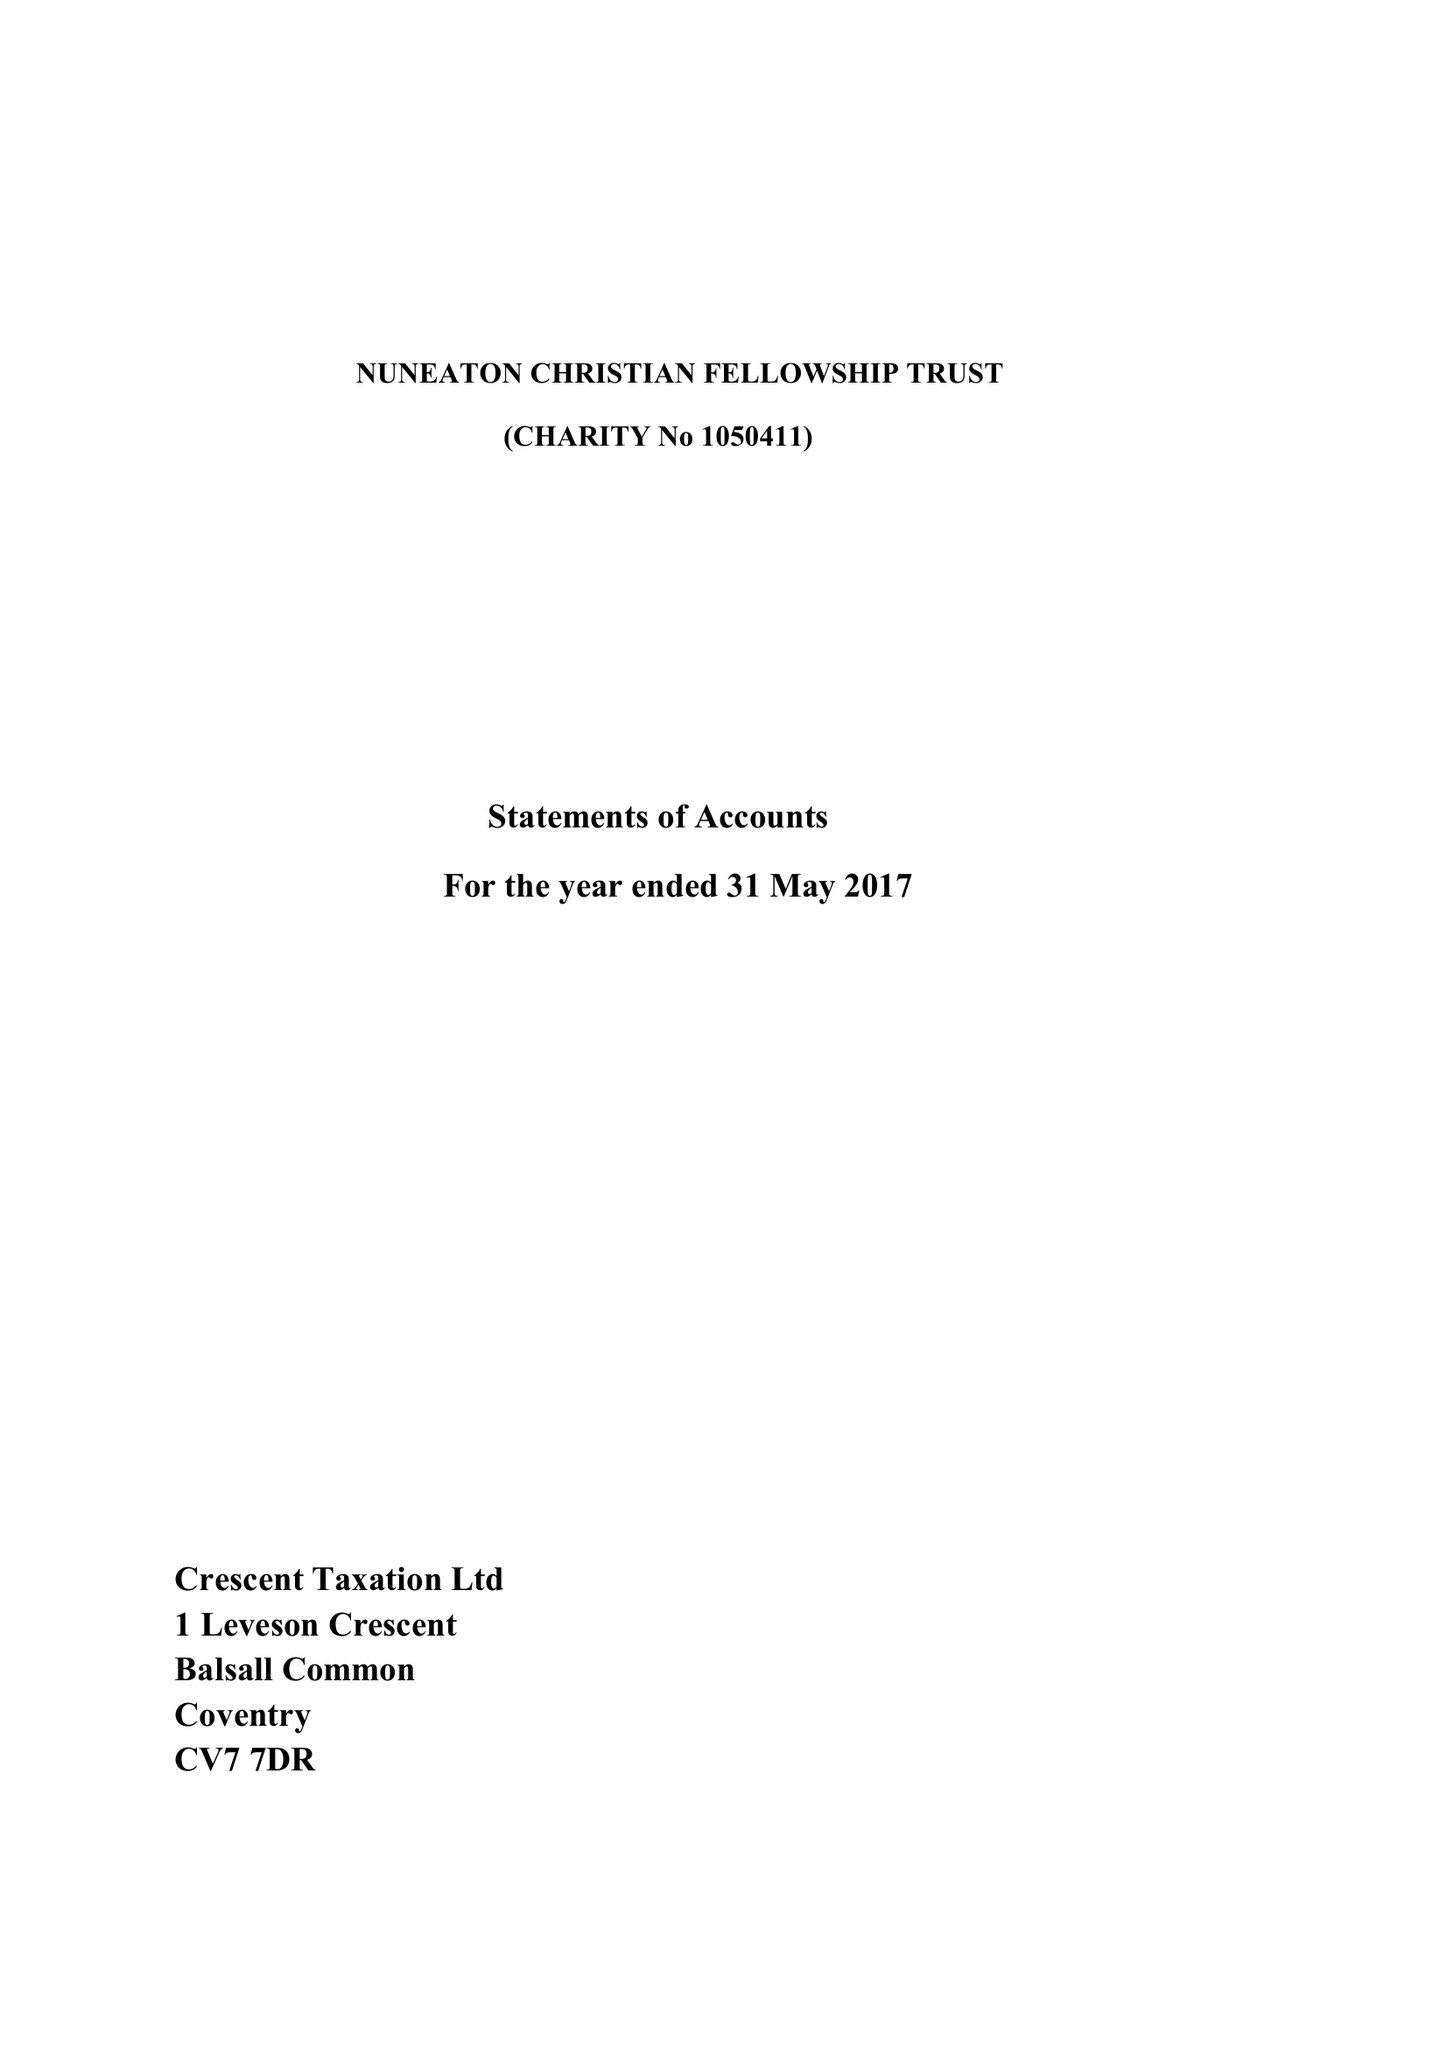What is the value for the address__street_line?
Answer the question using a single word or phrase. 58 PALLETT DRIVE 